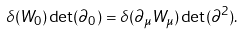<formula> <loc_0><loc_0><loc_500><loc_500>\delta ( W _ { 0 } ) \det ( \partial _ { 0 } ) = \delta ( \partial _ { \mu } W _ { \mu } ) \det ( \partial ^ { 2 } ) .</formula> 